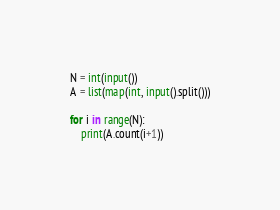<code> <loc_0><loc_0><loc_500><loc_500><_Python_>N = int(input())
A = list(map(int, input().split()))

for i in range(N):
    print(A.count(i+1))</code> 